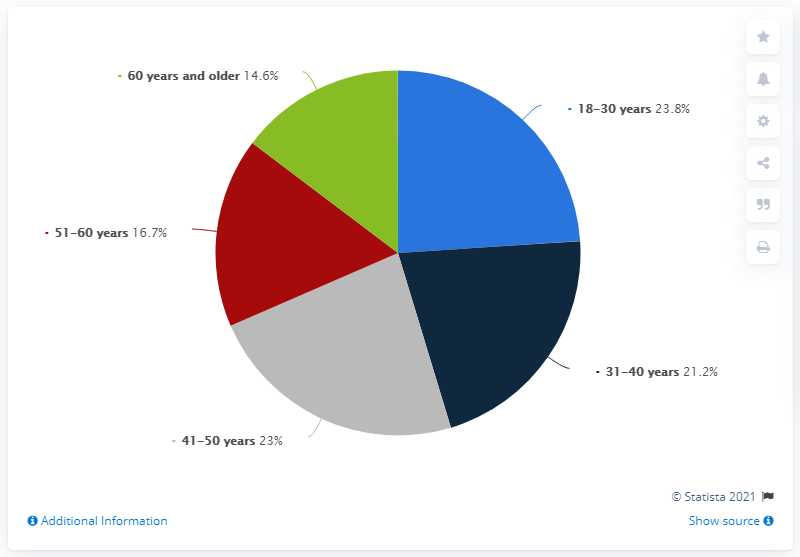Could you provide more context to these statistics? Certainly! The pie chart likely originates from a survey or a study aimed at understanding which age groups are most vulnerable to scams in Italy. The percentages suggest that middle-aged individuals, particularly those between 41-50 years, are the most targeted or susceptible. The reasons behind this could include factors such as this age group's higher likelihood of possessing disposable income and the potential for being less digitally native compared to the younger generation. However, the close percentages across the groups imply that scams are a widespread issue affecting a broad spectrum of the population. 